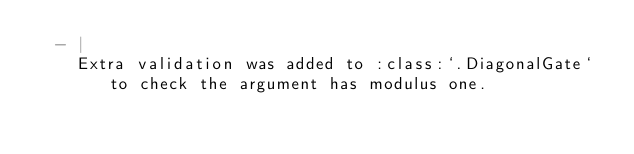<code> <loc_0><loc_0><loc_500><loc_500><_YAML_>  - |
    Extra validation was added to :class:`.DiagonalGate` to check the argument has modulus one.
</code> 